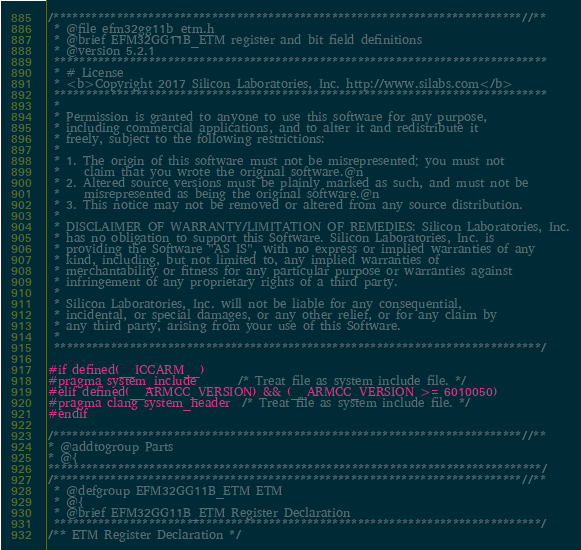<code> <loc_0><loc_0><loc_500><loc_500><_C_>/**************************************************************************//**
 * @file efm32gg11b_etm.h
 * @brief EFM32GG11B_ETM register and bit field definitions
 * @version 5.2.1
 ******************************************************************************
 * # License
 * <b>Copyright 2017 Silicon Laboratories, Inc. http://www.silabs.com</b>
 ******************************************************************************
 *
 * Permission is granted to anyone to use this software for any purpose,
 * including commercial applications, and to alter it and redistribute it
 * freely, subject to the following restrictions:
 *
 * 1. The origin of this software must not be misrepresented; you must not
 *    claim that you wrote the original software.@n
 * 2. Altered source versions must be plainly marked as such, and must not be
 *    misrepresented as being the original software.@n
 * 3. This notice may not be removed or altered from any source distribution.
 *
 * DISCLAIMER OF WARRANTY/LIMITATION OF REMEDIES: Silicon Laboratories, Inc.
 * has no obligation to support this Software. Silicon Laboratories, Inc. is
 * providing the Software "AS IS", with no express or implied warranties of any
 * kind, including, but not limited to, any implied warranties of
 * merchantability or fitness for any particular purpose or warranties against
 * infringement of any proprietary rights of a third party.
 *
 * Silicon Laboratories, Inc. will not be liable for any consequential,
 * incidental, or special damages, or any other relief, or for any claim by
 * any third party, arising from your use of this Software.
 *
 *****************************************************************************/

#if defined(__ICCARM__)
#pragma system_include       /* Treat file as system include file. */
#elif defined(__ARMCC_VERSION) && (__ARMCC_VERSION >= 6010050)
#pragma clang system_header  /* Treat file as system include file. */
#endif

/**************************************************************************//**
* @addtogroup Parts
* @{
******************************************************************************/
/**************************************************************************//**
 * @defgroup EFM32GG11B_ETM ETM
 * @{
 * @brief EFM32GG11B_ETM Register Declaration
 *****************************************************************************/
/** ETM Register Declaration */</code> 